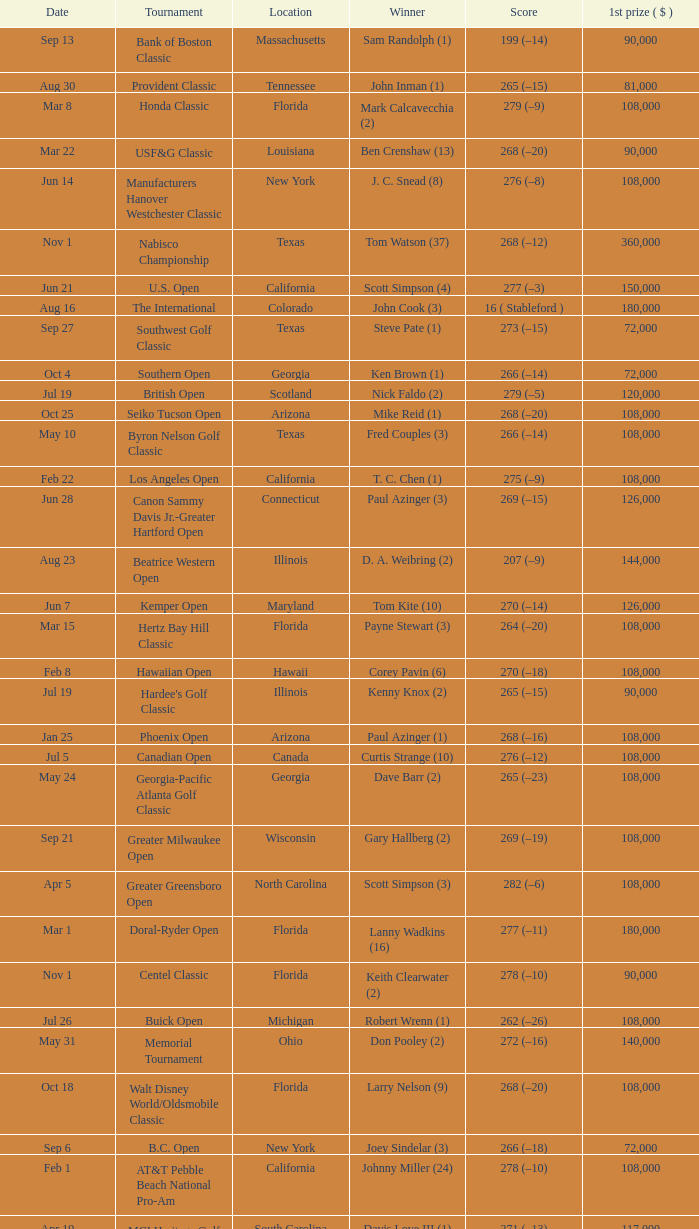What is the score from the winner Keith Clearwater (1)? 266 (–14). 